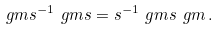<formula> <loc_0><loc_0><loc_500><loc_500>\ g m s ^ { - 1 } \ g m s = s ^ { - 1 } \ g m s \ g m \, .</formula> 